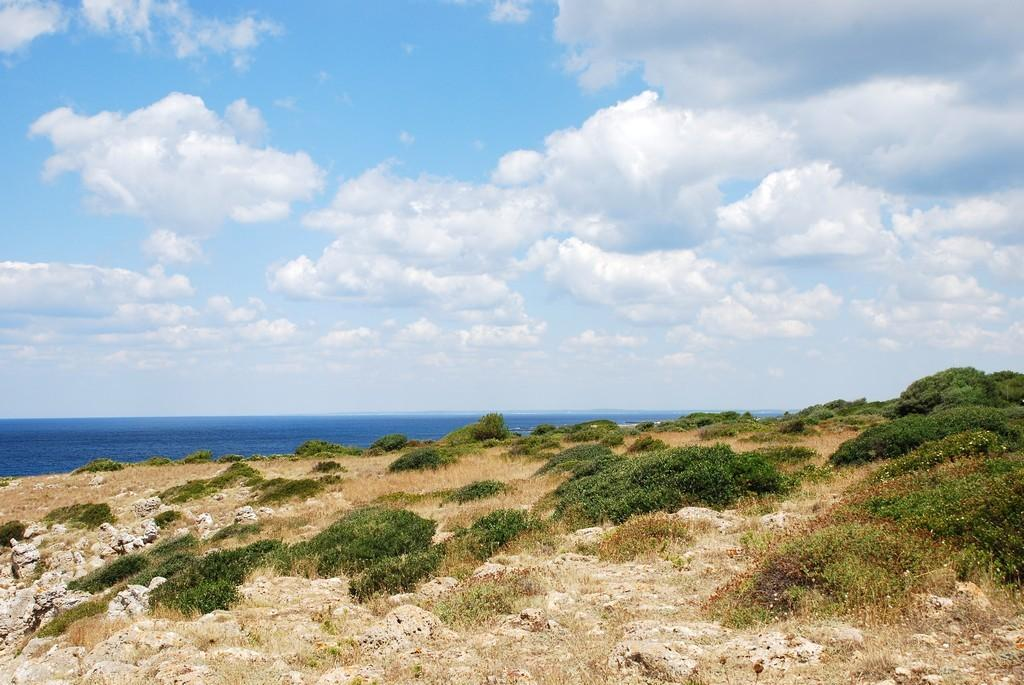Where was the image taken? The image was clicked outside the city. What can be seen in the foreground of the image? There is grass and plants in the foreground of the image. What is visible in the background of the image? There is a water body and the sky in the background of the image. What can be observed in the sky? There are clouds in the sky. What type of plot is being cultivated with lettuce in the image? There is no plot or lettuce present in the image; it features grass and plants in the foreground and a water body in the background. 